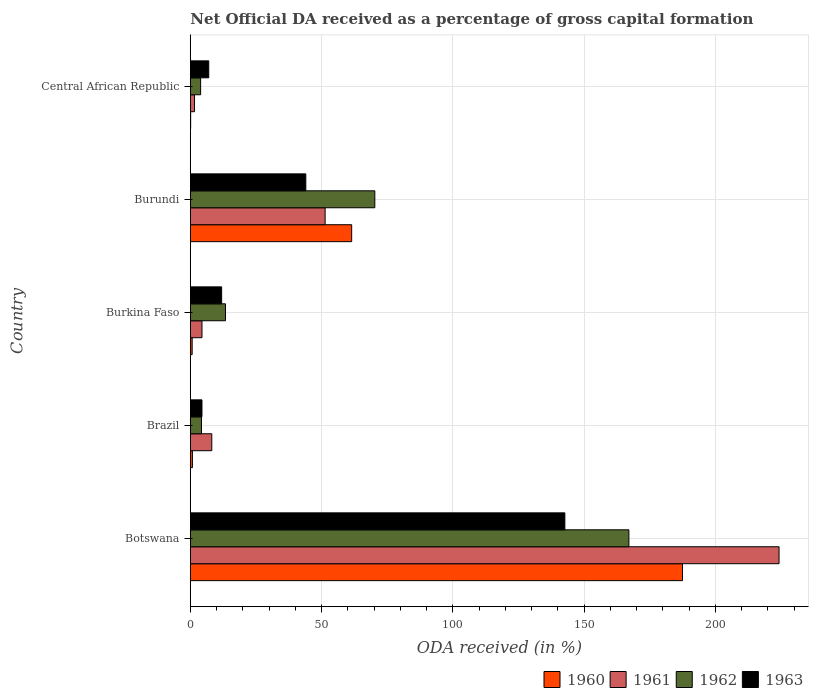How many different coloured bars are there?
Your answer should be very brief. 4. How many groups of bars are there?
Your response must be concise. 5. Are the number of bars on each tick of the Y-axis equal?
Offer a terse response. Yes. How many bars are there on the 1st tick from the top?
Provide a short and direct response. 4. How many bars are there on the 3rd tick from the bottom?
Provide a succinct answer. 4. What is the label of the 3rd group of bars from the top?
Your answer should be compact. Burkina Faso. In how many cases, is the number of bars for a given country not equal to the number of legend labels?
Offer a very short reply. 0. What is the net ODA received in 1962 in Central African Republic?
Give a very brief answer. 3.93. Across all countries, what is the maximum net ODA received in 1960?
Give a very brief answer. 187.49. Across all countries, what is the minimum net ODA received in 1963?
Provide a succinct answer. 4.45. In which country was the net ODA received in 1960 maximum?
Your answer should be compact. Botswana. In which country was the net ODA received in 1961 minimum?
Your answer should be compact. Central African Republic. What is the total net ODA received in 1961 in the graph?
Make the answer very short. 289.88. What is the difference between the net ODA received in 1962 in Brazil and that in Burkina Faso?
Ensure brevity in your answer.  -9.14. What is the difference between the net ODA received in 1962 in Brazil and the net ODA received in 1963 in Burkina Faso?
Ensure brevity in your answer.  -7.67. What is the average net ODA received in 1963 per country?
Your answer should be compact. 42.02. What is the difference between the net ODA received in 1963 and net ODA received in 1960 in Burkina Faso?
Your response must be concise. 11.23. In how many countries, is the net ODA received in 1962 greater than 130 %?
Give a very brief answer. 1. What is the ratio of the net ODA received in 1963 in Botswana to that in Burkina Faso?
Give a very brief answer. 11.95. What is the difference between the highest and the second highest net ODA received in 1961?
Offer a terse response. 172.91. What is the difference between the highest and the lowest net ODA received in 1963?
Offer a terse response. 138.23. In how many countries, is the net ODA received in 1962 greater than the average net ODA received in 1962 taken over all countries?
Provide a succinct answer. 2. Is the sum of the net ODA received in 1963 in Botswana and Brazil greater than the maximum net ODA received in 1960 across all countries?
Offer a very short reply. No. Is it the case that in every country, the sum of the net ODA received in 1962 and net ODA received in 1961 is greater than the sum of net ODA received in 1963 and net ODA received in 1960?
Ensure brevity in your answer.  No. What does the 1st bar from the top in Burkina Faso represents?
Your response must be concise. 1963. What is the difference between two consecutive major ticks on the X-axis?
Your answer should be very brief. 50. Does the graph contain any zero values?
Your response must be concise. No. Does the graph contain grids?
Ensure brevity in your answer.  Yes. Where does the legend appear in the graph?
Provide a short and direct response. Bottom right. How many legend labels are there?
Keep it short and to the point. 4. What is the title of the graph?
Keep it short and to the point. Net Official DA received as a percentage of gross capital formation. Does "1966" appear as one of the legend labels in the graph?
Your response must be concise. No. What is the label or title of the X-axis?
Give a very brief answer. ODA received (in %). What is the label or title of the Y-axis?
Offer a terse response. Country. What is the ODA received (in %) in 1960 in Botswana?
Your answer should be compact. 187.49. What is the ODA received (in %) of 1961 in Botswana?
Offer a terse response. 224.27. What is the ODA received (in %) in 1962 in Botswana?
Your response must be concise. 167.07. What is the ODA received (in %) of 1963 in Botswana?
Ensure brevity in your answer.  142.68. What is the ODA received (in %) in 1960 in Brazil?
Keep it short and to the point. 0.81. What is the ODA received (in %) in 1961 in Brazil?
Your response must be concise. 8.19. What is the ODA received (in %) of 1962 in Brazil?
Your answer should be compact. 4.26. What is the ODA received (in %) of 1963 in Brazil?
Make the answer very short. 4.45. What is the ODA received (in %) in 1960 in Burkina Faso?
Keep it short and to the point. 0.71. What is the ODA received (in %) in 1961 in Burkina Faso?
Your answer should be compact. 4.45. What is the ODA received (in %) in 1962 in Burkina Faso?
Offer a very short reply. 13.4. What is the ODA received (in %) in 1963 in Burkina Faso?
Make the answer very short. 11.94. What is the ODA received (in %) of 1960 in Burundi?
Your response must be concise. 61.47. What is the ODA received (in %) in 1961 in Burundi?
Your answer should be compact. 51.36. What is the ODA received (in %) of 1962 in Burundi?
Give a very brief answer. 70.29. What is the ODA received (in %) in 1963 in Burundi?
Make the answer very short. 44. What is the ODA received (in %) of 1960 in Central African Republic?
Provide a succinct answer. 0.14. What is the ODA received (in %) in 1961 in Central African Republic?
Provide a short and direct response. 1.61. What is the ODA received (in %) of 1962 in Central African Republic?
Offer a very short reply. 3.93. What is the ODA received (in %) of 1963 in Central African Republic?
Give a very brief answer. 7.03. Across all countries, what is the maximum ODA received (in %) of 1960?
Offer a very short reply. 187.49. Across all countries, what is the maximum ODA received (in %) in 1961?
Offer a terse response. 224.27. Across all countries, what is the maximum ODA received (in %) of 1962?
Ensure brevity in your answer.  167.07. Across all countries, what is the maximum ODA received (in %) of 1963?
Your response must be concise. 142.68. Across all countries, what is the minimum ODA received (in %) in 1960?
Offer a very short reply. 0.14. Across all countries, what is the minimum ODA received (in %) in 1961?
Your answer should be very brief. 1.61. Across all countries, what is the minimum ODA received (in %) of 1962?
Your response must be concise. 3.93. Across all countries, what is the minimum ODA received (in %) of 1963?
Offer a very short reply. 4.45. What is the total ODA received (in %) in 1960 in the graph?
Offer a very short reply. 250.61. What is the total ODA received (in %) of 1961 in the graph?
Offer a very short reply. 289.88. What is the total ODA received (in %) of 1962 in the graph?
Provide a succinct answer. 258.96. What is the total ODA received (in %) in 1963 in the graph?
Your answer should be very brief. 210.09. What is the difference between the ODA received (in %) of 1960 in Botswana and that in Brazil?
Offer a terse response. 186.68. What is the difference between the ODA received (in %) in 1961 in Botswana and that in Brazil?
Your answer should be compact. 216.07. What is the difference between the ODA received (in %) in 1962 in Botswana and that in Brazil?
Offer a very short reply. 162.81. What is the difference between the ODA received (in %) of 1963 in Botswana and that in Brazil?
Offer a very short reply. 138.23. What is the difference between the ODA received (in %) of 1960 in Botswana and that in Burkina Faso?
Your answer should be compact. 186.78. What is the difference between the ODA received (in %) of 1961 in Botswana and that in Burkina Faso?
Your response must be concise. 219.81. What is the difference between the ODA received (in %) of 1962 in Botswana and that in Burkina Faso?
Give a very brief answer. 153.67. What is the difference between the ODA received (in %) of 1963 in Botswana and that in Burkina Faso?
Provide a succinct answer. 130.74. What is the difference between the ODA received (in %) in 1960 in Botswana and that in Burundi?
Offer a terse response. 126.02. What is the difference between the ODA received (in %) of 1961 in Botswana and that in Burundi?
Provide a short and direct response. 172.91. What is the difference between the ODA received (in %) in 1962 in Botswana and that in Burundi?
Provide a succinct answer. 96.78. What is the difference between the ODA received (in %) of 1963 in Botswana and that in Burundi?
Offer a terse response. 98.68. What is the difference between the ODA received (in %) in 1960 in Botswana and that in Central African Republic?
Provide a succinct answer. 187.35. What is the difference between the ODA received (in %) of 1961 in Botswana and that in Central African Republic?
Offer a terse response. 222.66. What is the difference between the ODA received (in %) in 1962 in Botswana and that in Central African Republic?
Provide a short and direct response. 163.14. What is the difference between the ODA received (in %) of 1963 in Botswana and that in Central African Republic?
Your answer should be very brief. 135.65. What is the difference between the ODA received (in %) in 1960 in Brazil and that in Burkina Faso?
Your answer should be very brief. 0.1. What is the difference between the ODA received (in %) of 1961 in Brazil and that in Burkina Faso?
Give a very brief answer. 3.74. What is the difference between the ODA received (in %) of 1962 in Brazil and that in Burkina Faso?
Give a very brief answer. -9.14. What is the difference between the ODA received (in %) of 1963 in Brazil and that in Burkina Faso?
Give a very brief answer. -7.49. What is the difference between the ODA received (in %) in 1960 in Brazil and that in Burundi?
Your answer should be very brief. -60.66. What is the difference between the ODA received (in %) of 1961 in Brazil and that in Burundi?
Provide a short and direct response. -43.17. What is the difference between the ODA received (in %) in 1962 in Brazil and that in Burundi?
Keep it short and to the point. -66.02. What is the difference between the ODA received (in %) of 1963 in Brazil and that in Burundi?
Give a very brief answer. -39.55. What is the difference between the ODA received (in %) of 1960 in Brazil and that in Central African Republic?
Your answer should be very brief. 0.67. What is the difference between the ODA received (in %) in 1961 in Brazil and that in Central African Republic?
Your response must be concise. 6.58. What is the difference between the ODA received (in %) in 1962 in Brazil and that in Central African Republic?
Give a very brief answer. 0.33. What is the difference between the ODA received (in %) in 1963 in Brazil and that in Central African Republic?
Ensure brevity in your answer.  -2.58. What is the difference between the ODA received (in %) in 1960 in Burkina Faso and that in Burundi?
Ensure brevity in your answer.  -60.76. What is the difference between the ODA received (in %) in 1961 in Burkina Faso and that in Burundi?
Your answer should be compact. -46.9. What is the difference between the ODA received (in %) in 1962 in Burkina Faso and that in Burundi?
Make the answer very short. -56.88. What is the difference between the ODA received (in %) in 1963 in Burkina Faso and that in Burundi?
Give a very brief answer. -32.06. What is the difference between the ODA received (in %) of 1960 in Burkina Faso and that in Central African Republic?
Ensure brevity in your answer.  0.57. What is the difference between the ODA received (in %) of 1961 in Burkina Faso and that in Central African Republic?
Keep it short and to the point. 2.84. What is the difference between the ODA received (in %) of 1962 in Burkina Faso and that in Central African Republic?
Provide a succinct answer. 9.47. What is the difference between the ODA received (in %) in 1963 in Burkina Faso and that in Central African Republic?
Your answer should be very brief. 4.91. What is the difference between the ODA received (in %) in 1960 in Burundi and that in Central African Republic?
Your answer should be very brief. 61.33. What is the difference between the ODA received (in %) of 1961 in Burundi and that in Central African Republic?
Make the answer very short. 49.75. What is the difference between the ODA received (in %) in 1962 in Burundi and that in Central African Republic?
Give a very brief answer. 66.35. What is the difference between the ODA received (in %) in 1963 in Burundi and that in Central African Republic?
Your answer should be compact. 36.97. What is the difference between the ODA received (in %) in 1960 in Botswana and the ODA received (in %) in 1961 in Brazil?
Keep it short and to the point. 179.29. What is the difference between the ODA received (in %) in 1960 in Botswana and the ODA received (in %) in 1962 in Brazil?
Provide a succinct answer. 183.22. What is the difference between the ODA received (in %) in 1960 in Botswana and the ODA received (in %) in 1963 in Brazil?
Give a very brief answer. 183.04. What is the difference between the ODA received (in %) of 1961 in Botswana and the ODA received (in %) of 1962 in Brazil?
Keep it short and to the point. 220. What is the difference between the ODA received (in %) of 1961 in Botswana and the ODA received (in %) of 1963 in Brazil?
Offer a terse response. 219.82. What is the difference between the ODA received (in %) of 1962 in Botswana and the ODA received (in %) of 1963 in Brazil?
Provide a succinct answer. 162.62. What is the difference between the ODA received (in %) in 1960 in Botswana and the ODA received (in %) in 1961 in Burkina Faso?
Make the answer very short. 183.03. What is the difference between the ODA received (in %) of 1960 in Botswana and the ODA received (in %) of 1962 in Burkina Faso?
Provide a succinct answer. 174.08. What is the difference between the ODA received (in %) of 1960 in Botswana and the ODA received (in %) of 1963 in Burkina Faso?
Your response must be concise. 175.55. What is the difference between the ODA received (in %) of 1961 in Botswana and the ODA received (in %) of 1962 in Burkina Faso?
Ensure brevity in your answer.  210.86. What is the difference between the ODA received (in %) of 1961 in Botswana and the ODA received (in %) of 1963 in Burkina Faso?
Offer a terse response. 212.33. What is the difference between the ODA received (in %) in 1962 in Botswana and the ODA received (in %) in 1963 in Burkina Faso?
Your response must be concise. 155.13. What is the difference between the ODA received (in %) in 1960 in Botswana and the ODA received (in %) in 1961 in Burundi?
Your answer should be compact. 136.13. What is the difference between the ODA received (in %) of 1960 in Botswana and the ODA received (in %) of 1962 in Burundi?
Provide a short and direct response. 117.2. What is the difference between the ODA received (in %) of 1960 in Botswana and the ODA received (in %) of 1963 in Burundi?
Give a very brief answer. 143.49. What is the difference between the ODA received (in %) in 1961 in Botswana and the ODA received (in %) in 1962 in Burundi?
Provide a short and direct response. 153.98. What is the difference between the ODA received (in %) in 1961 in Botswana and the ODA received (in %) in 1963 in Burundi?
Ensure brevity in your answer.  180.27. What is the difference between the ODA received (in %) of 1962 in Botswana and the ODA received (in %) of 1963 in Burundi?
Your answer should be very brief. 123.07. What is the difference between the ODA received (in %) in 1960 in Botswana and the ODA received (in %) in 1961 in Central African Republic?
Your response must be concise. 185.88. What is the difference between the ODA received (in %) in 1960 in Botswana and the ODA received (in %) in 1962 in Central African Republic?
Provide a short and direct response. 183.55. What is the difference between the ODA received (in %) of 1960 in Botswana and the ODA received (in %) of 1963 in Central African Republic?
Give a very brief answer. 180.46. What is the difference between the ODA received (in %) of 1961 in Botswana and the ODA received (in %) of 1962 in Central African Republic?
Your response must be concise. 220.33. What is the difference between the ODA received (in %) in 1961 in Botswana and the ODA received (in %) in 1963 in Central African Republic?
Your answer should be compact. 217.24. What is the difference between the ODA received (in %) in 1962 in Botswana and the ODA received (in %) in 1963 in Central African Republic?
Give a very brief answer. 160.04. What is the difference between the ODA received (in %) in 1960 in Brazil and the ODA received (in %) in 1961 in Burkina Faso?
Your response must be concise. -3.65. What is the difference between the ODA received (in %) of 1960 in Brazil and the ODA received (in %) of 1962 in Burkina Faso?
Make the answer very short. -12.6. What is the difference between the ODA received (in %) of 1960 in Brazil and the ODA received (in %) of 1963 in Burkina Faso?
Provide a short and direct response. -11.13. What is the difference between the ODA received (in %) of 1961 in Brazil and the ODA received (in %) of 1962 in Burkina Faso?
Your response must be concise. -5.21. What is the difference between the ODA received (in %) in 1961 in Brazil and the ODA received (in %) in 1963 in Burkina Faso?
Give a very brief answer. -3.75. What is the difference between the ODA received (in %) of 1962 in Brazil and the ODA received (in %) of 1963 in Burkina Faso?
Your answer should be compact. -7.67. What is the difference between the ODA received (in %) in 1960 in Brazil and the ODA received (in %) in 1961 in Burundi?
Offer a very short reply. -50.55. What is the difference between the ODA received (in %) of 1960 in Brazil and the ODA received (in %) of 1962 in Burundi?
Your answer should be compact. -69.48. What is the difference between the ODA received (in %) of 1960 in Brazil and the ODA received (in %) of 1963 in Burundi?
Your answer should be compact. -43.19. What is the difference between the ODA received (in %) of 1961 in Brazil and the ODA received (in %) of 1962 in Burundi?
Offer a terse response. -62.09. What is the difference between the ODA received (in %) of 1961 in Brazil and the ODA received (in %) of 1963 in Burundi?
Keep it short and to the point. -35.81. What is the difference between the ODA received (in %) in 1962 in Brazil and the ODA received (in %) in 1963 in Burundi?
Provide a succinct answer. -39.74. What is the difference between the ODA received (in %) in 1960 in Brazil and the ODA received (in %) in 1961 in Central African Republic?
Keep it short and to the point. -0.8. What is the difference between the ODA received (in %) of 1960 in Brazil and the ODA received (in %) of 1962 in Central African Republic?
Your response must be concise. -3.13. What is the difference between the ODA received (in %) of 1960 in Brazil and the ODA received (in %) of 1963 in Central African Republic?
Offer a terse response. -6.22. What is the difference between the ODA received (in %) in 1961 in Brazil and the ODA received (in %) in 1962 in Central African Republic?
Your answer should be very brief. 4.26. What is the difference between the ODA received (in %) in 1961 in Brazil and the ODA received (in %) in 1963 in Central African Republic?
Ensure brevity in your answer.  1.16. What is the difference between the ODA received (in %) of 1962 in Brazil and the ODA received (in %) of 1963 in Central African Republic?
Your response must be concise. -2.77. What is the difference between the ODA received (in %) in 1960 in Burkina Faso and the ODA received (in %) in 1961 in Burundi?
Offer a terse response. -50.65. What is the difference between the ODA received (in %) in 1960 in Burkina Faso and the ODA received (in %) in 1962 in Burundi?
Ensure brevity in your answer.  -69.58. What is the difference between the ODA received (in %) in 1960 in Burkina Faso and the ODA received (in %) in 1963 in Burundi?
Provide a succinct answer. -43.29. What is the difference between the ODA received (in %) of 1961 in Burkina Faso and the ODA received (in %) of 1962 in Burundi?
Your answer should be compact. -65.83. What is the difference between the ODA received (in %) of 1961 in Burkina Faso and the ODA received (in %) of 1963 in Burundi?
Your answer should be very brief. -39.55. What is the difference between the ODA received (in %) of 1962 in Burkina Faso and the ODA received (in %) of 1963 in Burundi?
Ensure brevity in your answer.  -30.6. What is the difference between the ODA received (in %) of 1960 in Burkina Faso and the ODA received (in %) of 1961 in Central African Republic?
Keep it short and to the point. -0.9. What is the difference between the ODA received (in %) in 1960 in Burkina Faso and the ODA received (in %) in 1962 in Central African Republic?
Provide a short and direct response. -3.22. What is the difference between the ODA received (in %) in 1960 in Burkina Faso and the ODA received (in %) in 1963 in Central African Republic?
Provide a short and direct response. -6.32. What is the difference between the ODA received (in %) in 1961 in Burkina Faso and the ODA received (in %) in 1962 in Central African Republic?
Your answer should be very brief. 0.52. What is the difference between the ODA received (in %) in 1961 in Burkina Faso and the ODA received (in %) in 1963 in Central African Republic?
Offer a very short reply. -2.58. What is the difference between the ODA received (in %) in 1962 in Burkina Faso and the ODA received (in %) in 1963 in Central African Republic?
Make the answer very short. 6.37. What is the difference between the ODA received (in %) in 1960 in Burundi and the ODA received (in %) in 1961 in Central African Republic?
Ensure brevity in your answer.  59.86. What is the difference between the ODA received (in %) of 1960 in Burundi and the ODA received (in %) of 1962 in Central African Republic?
Your answer should be compact. 57.54. What is the difference between the ODA received (in %) of 1960 in Burundi and the ODA received (in %) of 1963 in Central African Republic?
Give a very brief answer. 54.44. What is the difference between the ODA received (in %) in 1961 in Burundi and the ODA received (in %) in 1962 in Central African Republic?
Your response must be concise. 47.42. What is the difference between the ODA received (in %) of 1961 in Burundi and the ODA received (in %) of 1963 in Central African Republic?
Give a very brief answer. 44.33. What is the difference between the ODA received (in %) of 1962 in Burundi and the ODA received (in %) of 1963 in Central African Republic?
Your answer should be very brief. 63.25. What is the average ODA received (in %) in 1960 per country?
Your response must be concise. 50.12. What is the average ODA received (in %) in 1961 per country?
Keep it short and to the point. 57.98. What is the average ODA received (in %) of 1962 per country?
Give a very brief answer. 51.79. What is the average ODA received (in %) in 1963 per country?
Ensure brevity in your answer.  42.02. What is the difference between the ODA received (in %) in 1960 and ODA received (in %) in 1961 in Botswana?
Offer a very short reply. -36.78. What is the difference between the ODA received (in %) in 1960 and ODA received (in %) in 1962 in Botswana?
Make the answer very short. 20.42. What is the difference between the ODA received (in %) in 1960 and ODA received (in %) in 1963 in Botswana?
Keep it short and to the point. 44.81. What is the difference between the ODA received (in %) in 1961 and ODA received (in %) in 1962 in Botswana?
Ensure brevity in your answer.  57.2. What is the difference between the ODA received (in %) in 1961 and ODA received (in %) in 1963 in Botswana?
Provide a short and direct response. 81.59. What is the difference between the ODA received (in %) in 1962 and ODA received (in %) in 1963 in Botswana?
Offer a very short reply. 24.39. What is the difference between the ODA received (in %) in 1960 and ODA received (in %) in 1961 in Brazil?
Keep it short and to the point. -7.38. What is the difference between the ODA received (in %) of 1960 and ODA received (in %) of 1962 in Brazil?
Offer a very short reply. -3.46. What is the difference between the ODA received (in %) in 1960 and ODA received (in %) in 1963 in Brazil?
Ensure brevity in your answer.  -3.64. What is the difference between the ODA received (in %) in 1961 and ODA received (in %) in 1962 in Brazil?
Your answer should be very brief. 3.93. What is the difference between the ODA received (in %) in 1961 and ODA received (in %) in 1963 in Brazil?
Provide a short and direct response. 3.74. What is the difference between the ODA received (in %) in 1962 and ODA received (in %) in 1963 in Brazil?
Offer a terse response. -0.18. What is the difference between the ODA received (in %) of 1960 and ODA received (in %) of 1961 in Burkina Faso?
Give a very brief answer. -3.74. What is the difference between the ODA received (in %) in 1960 and ODA received (in %) in 1962 in Burkina Faso?
Your response must be concise. -12.69. What is the difference between the ODA received (in %) of 1960 and ODA received (in %) of 1963 in Burkina Faso?
Keep it short and to the point. -11.23. What is the difference between the ODA received (in %) of 1961 and ODA received (in %) of 1962 in Burkina Faso?
Provide a short and direct response. -8.95. What is the difference between the ODA received (in %) in 1961 and ODA received (in %) in 1963 in Burkina Faso?
Make the answer very short. -7.48. What is the difference between the ODA received (in %) of 1962 and ODA received (in %) of 1963 in Burkina Faso?
Give a very brief answer. 1.47. What is the difference between the ODA received (in %) in 1960 and ODA received (in %) in 1961 in Burundi?
Offer a very short reply. 10.11. What is the difference between the ODA received (in %) of 1960 and ODA received (in %) of 1962 in Burundi?
Your answer should be compact. -8.82. What is the difference between the ODA received (in %) of 1960 and ODA received (in %) of 1963 in Burundi?
Give a very brief answer. 17.47. What is the difference between the ODA received (in %) in 1961 and ODA received (in %) in 1962 in Burundi?
Give a very brief answer. -18.93. What is the difference between the ODA received (in %) in 1961 and ODA received (in %) in 1963 in Burundi?
Your answer should be very brief. 7.36. What is the difference between the ODA received (in %) in 1962 and ODA received (in %) in 1963 in Burundi?
Your answer should be compact. 26.29. What is the difference between the ODA received (in %) in 1960 and ODA received (in %) in 1961 in Central African Republic?
Make the answer very short. -1.47. What is the difference between the ODA received (in %) of 1960 and ODA received (in %) of 1962 in Central African Republic?
Your response must be concise. -3.8. What is the difference between the ODA received (in %) in 1960 and ODA received (in %) in 1963 in Central African Republic?
Offer a very short reply. -6.89. What is the difference between the ODA received (in %) of 1961 and ODA received (in %) of 1962 in Central African Republic?
Provide a short and direct response. -2.32. What is the difference between the ODA received (in %) of 1961 and ODA received (in %) of 1963 in Central African Republic?
Your response must be concise. -5.42. What is the difference between the ODA received (in %) in 1962 and ODA received (in %) in 1963 in Central African Republic?
Offer a terse response. -3.1. What is the ratio of the ODA received (in %) of 1960 in Botswana to that in Brazil?
Your answer should be compact. 232.07. What is the ratio of the ODA received (in %) in 1961 in Botswana to that in Brazil?
Offer a very short reply. 27.38. What is the ratio of the ODA received (in %) of 1962 in Botswana to that in Brazil?
Give a very brief answer. 39.18. What is the ratio of the ODA received (in %) of 1963 in Botswana to that in Brazil?
Give a very brief answer. 32.07. What is the ratio of the ODA received (in %) of 1960 in Botswana to that in Burkina Faso?
Keep it short and to the point. 263.92. What is the ratio of the ODA received (in %) in 1961 in Botswana to that in Burkina Faso?
Your answer should be compact. 50.35. What is the ratio of the ODA received (in %) of 1962 in Botswana to that in Burkina Faso?
Ensure brevity in your answer.  12.46. What is the ratio of the ODA received (in %) in 1963 in Botswana to that in Burkina Faso?
Provide a succinct answer. 11.95. What is the ratio of the ODA received (in %) in 1960 in Botswana to that in Burundi?
Your answer should be compact. 3.05. What is the ratio of the ODA received (in %) in 1961 in Botswana to that in Burundi?
Ensure brevity in your answer.  4.37. What is the ratio of the ODA received (in %) of 1962 in Botswana to that in Burundi?
Your response must be concise. 2.38. What is the ratio of the ODA received (in %) of 1963 in Botswana to that in Burundi?
Ensure brevity in your answer.  3.24. What is the ratio of the ODA received (in %) in 1960 in Botswana to that in Central African Republic?
Keep it short and to the point. 1376.35. What is the ratio of the ODA received (in %) of 1961 in Botswana to that in Central African Republic?
Your answer should be compact. 139.34. What is the ratio of the ODA received (in %) of 1962 in Botswana to that in Central African Republic?
Ensure brevity in your answer.  42.47. What is the ratio of the ODA received (in %) of 1963 in Botswana to that in Central African Republic?
Your response must be concise. 20.29. What is the ratio of the ODA received (in %) of 1960 in Brazil to that in Burkina Faso?
Offer a terse response. 1.14. What is the ratio of the ODA received (in %) in 1961 in Brazil to that in Burkina Faso?
Provide a short and direct response. 1.84. What is the ratio of the ODA received (in %) in 1962 in Brazil to that in Burkina Faso?
Keep it short and to the point. 0.32. What is the ratio of the ODA received (in %) in 1963 in Brazil to that in Burkina Faso?
Your answer should be compact. 0.37. What is the ratio of the ODA received (in %) in 1960 in Brazil to that in Burundi?
Your answer should be compact. 0.01. What is the ratio of the ODA received (in %) in 1961 in Brazil to that in Burundi?
Give a very brief answer. 0.16. What is the ratio of the ODA received (in %) of 1962 in Brazil to that in Burundi?
Give a very brief answer. 0.06. What is the ratio of the ODA received (in %) of 1963 in Brazil to that in Burundi?
Give a very brief answer. 0.1. What is the ratio of the ODA received (in %) in 1960 in Brazil to that in Central African Republic?
Make the answer very short. 5.93. What is the ratio of the ODA received (in %) in 1961 in Brazil to that in Central African Republic?
Keep it short and to the point. 5.09. What is the ratio of the ODA received (in %) in 1962 in Brazil to that in Central African Republic?
Make the answer very short. 1.08. What is the ratio of the ODA received (in %) in 1963 in Brazil to that in Central African Republic?
Your response must be concise. 0.63. What is the ratio of the ODA received (in %) in 1960 in Burkina Faso to that in Burundi?
Provide a succinct answer. 0.01. What is the ratio of the ODA received (in %) in 1961 in Burkina Faso to that in Burundi?
Ensure brevity in your answer.  0.09. What is the ratio of the ODA received (in %) in 1962 in Burkina Faso to that in Burundi?
Your answer should be compact. 0.19. What is the ratio of the ODA received (in %) of 1963 in Burkina Faso to that in Burundi?
Provide a succinct answer. 0.27. What is the ratio of the ODA received (in %) of 1960 in Burkina Faso to that in Central African Republic?
Your answer should be compact. 5.21. What is the ratio of the ODA received (in %) of 1961 in Burkina Faso to that in Central African Republic?
Your response must be concise. 2.77. What is the ratio of the ODA received (in %) of 1962 in Burkina Faso to that in Central African Republic?
Keep it short and to the point. 3.41. What is the ratio of the ODA received (in %) in 1963 in Burkina Faso to that in Central African Republic?
Offer a very short reply. 1.7. What is the ratio of the ODA received (in %) in 1960 in Burundi to that in Central African Republic?
Make the answer very short. 451.25. What is the ratio of the ODA received (in %) in 1961 in Burundi to that in Central African Republic?
Give a very brief answer. 31.91. What is the ratio of the ODA received (in %) of 1962 in Burundi to that in Central African Republic?
Your response must be concise. 17.87. What is the ratio of the ODA received (in %) of 1963 in Burundi to that in Central African Republic?
Offer a very short reply. 6.26. What is the difference between the highest and the second highest ODA received (in %) of 1960?
Make the answer very short. 126.02. What is the difference between the highest and the second highest ODA received (in %) in 1961?
Make the answer very short. 172.91. What is the difference between the highest and the second highest ODA received (in %) of 1962?
Keep it short and to the point. 96.78. What is the difference between the highest and the second highest ODA received (in %) in 1963?
Provide a short and direct response. 98.68. What is the difference between the highest and the lowest ODA received (in %) in 1960?
Offer a very short reply. 187.35. What is the difference between the highest and the lowest ODA received (in %) of 1961?
Offer a very short reply. 222.66. What is the difference between the highest and the lowest ODA received (in %) of 1962?
Keep it short and to the point. 163.14. What is the difference between the highest and the lowest ODA received (in %) in 1963?
Provide a short and direct response. 138.23. 